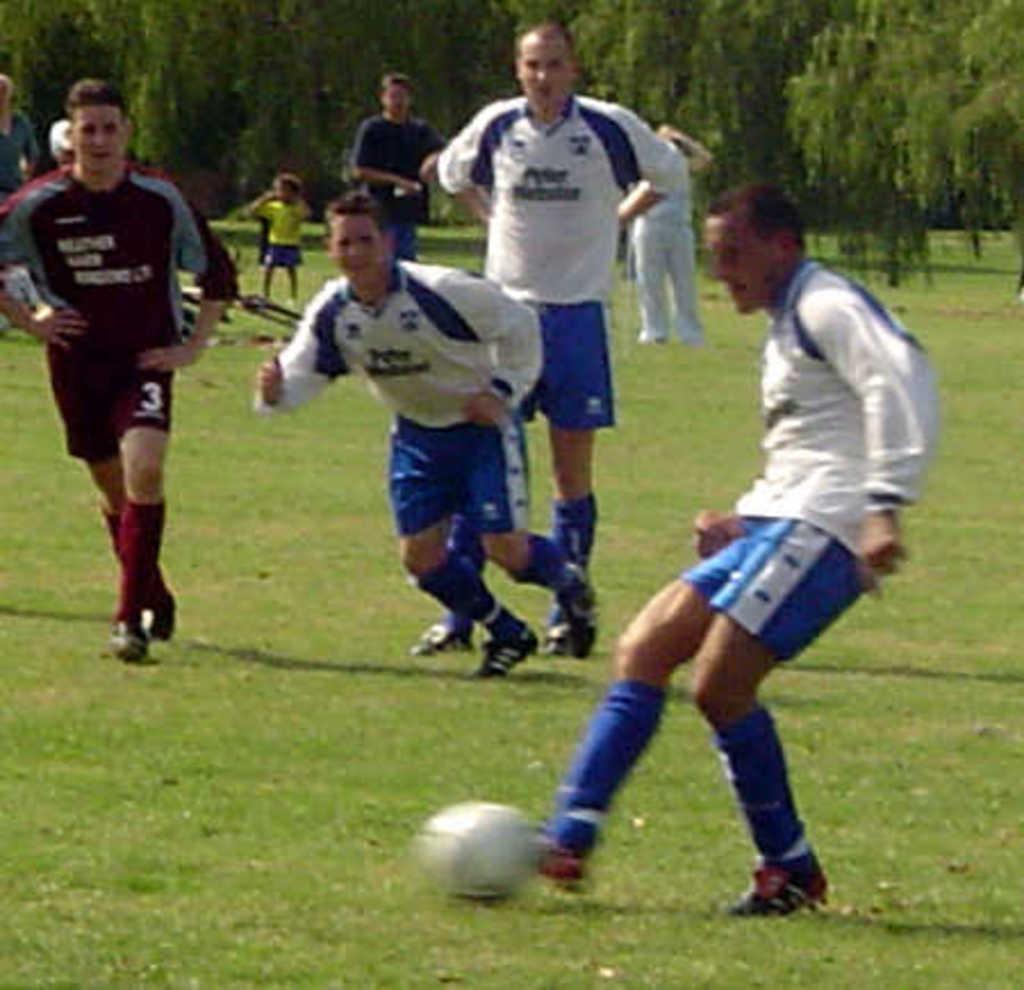Please provide a concise description of this image. This picture is clicked in a garden. There are few people playing football. The man to the right corner is kicking the ball. In the background there are trees and few people standing. To the below there is grass. 